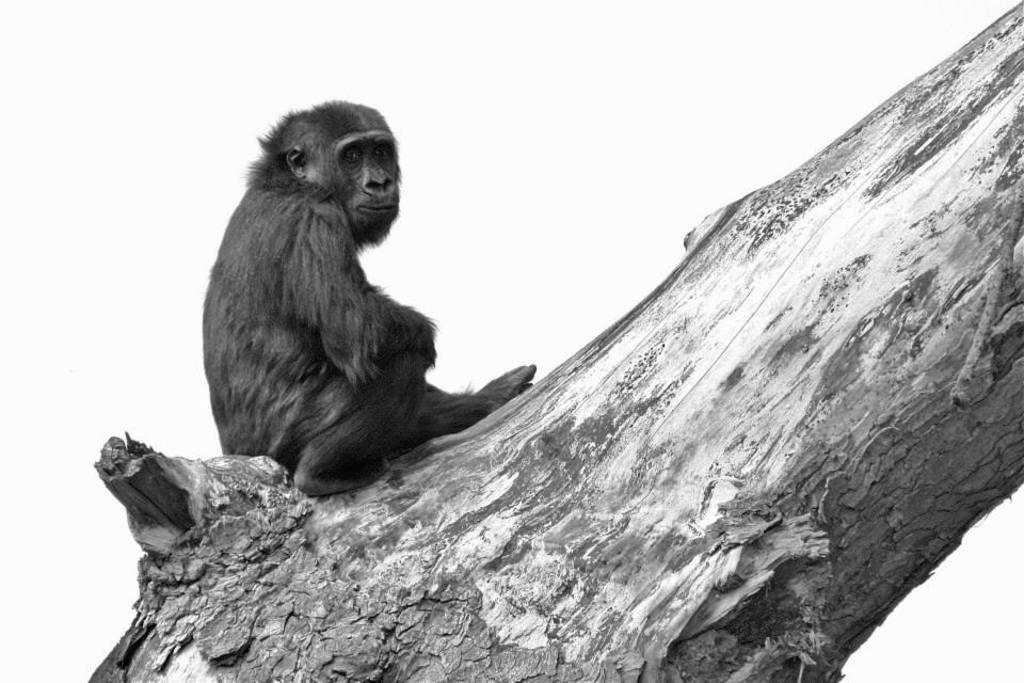Could you give a brief overview of what you see in this image? In this image there is a monkey on the bark of a tree. In the background of the image there is sky. 